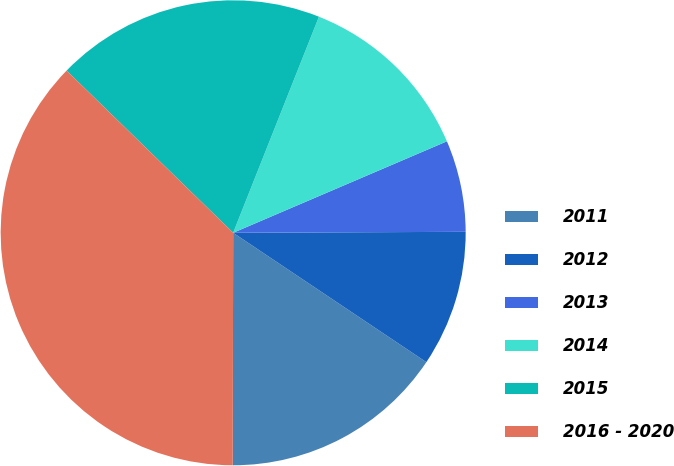Convert chart. <chart><loc_0><loc_0><loc_500><loc_500><pie_chart><fcel>2011<fcel>2012<fcel>2013<fcel>2014<fcel>2015<fcel>2016 - 2020<nl><fcel>15.64%<fcel>9.46%<fcel>6.37%<fcel>12.55%<fcel>18.73%<fcel>37.26%<nl></chart> 